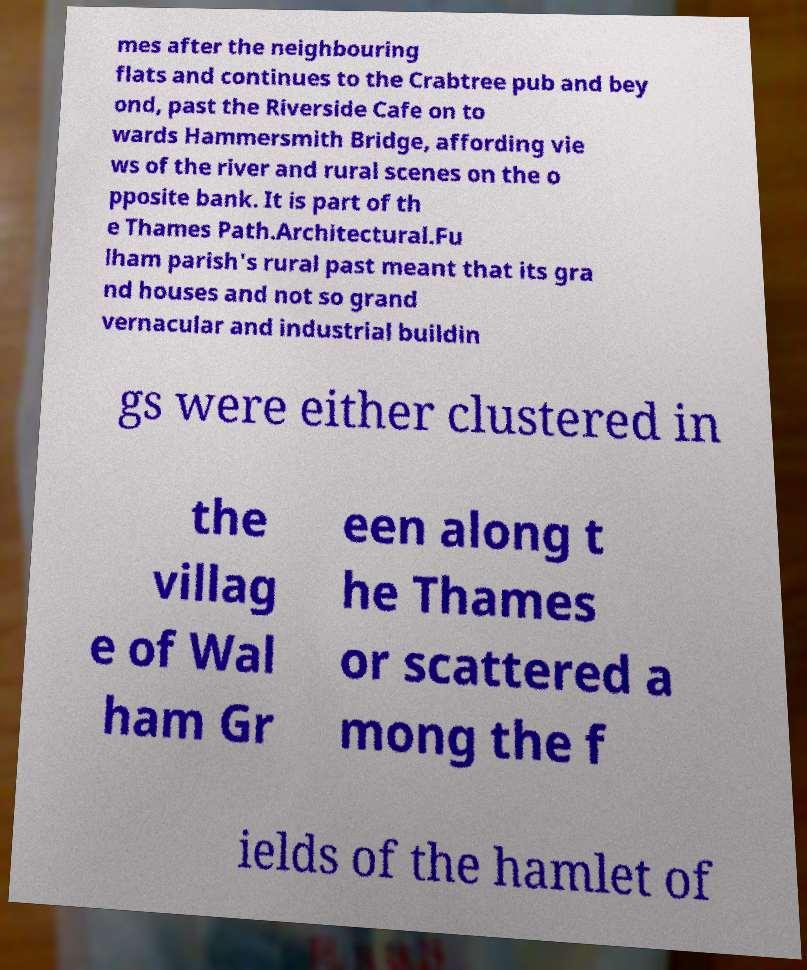Please identify and transcribe the text found in this image. mes after the neighbouring flats and continues to the Crabtree pub and bey ond, past the Riverside Cafe on to wards Hammersmith Bridge, affording vie ws of the river and rural scenes on the o pposite bank. It is part of th e Thames Path.Architectural.Fu lham parish's rural past meant that its gra nd houses and not so grand vernacular and industrial buildin gs were either clustered in the villag e of Wal ham Gr een along t he Thames or scattered a mong the f ields of the hamlet of 